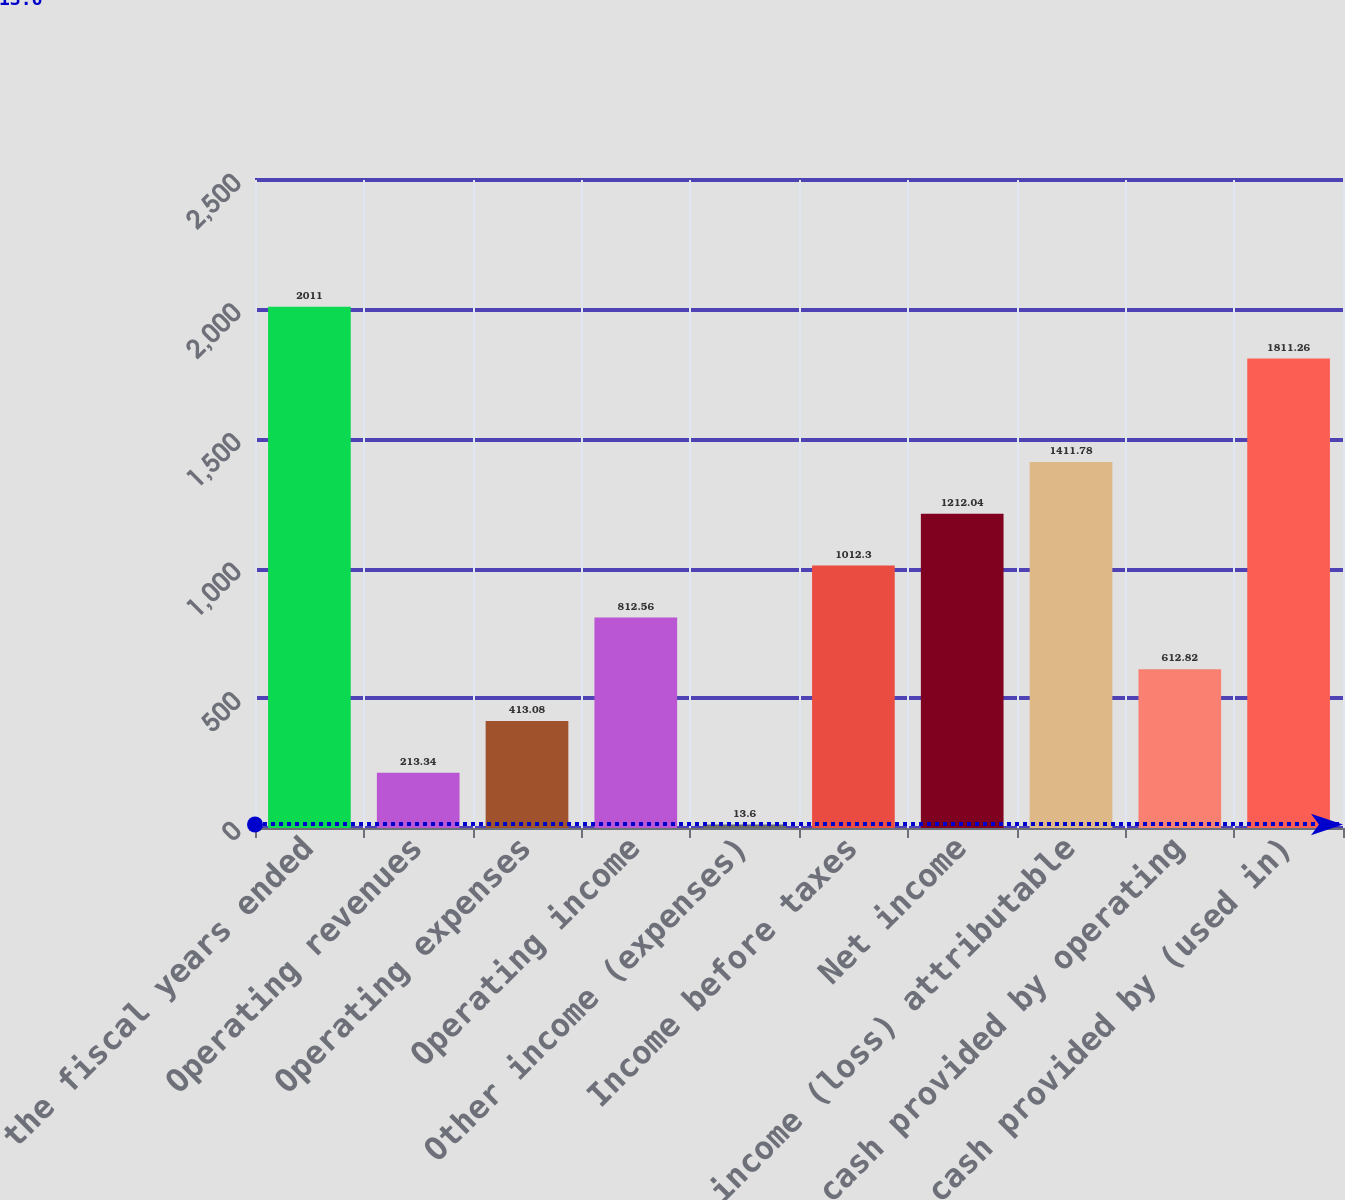Convert chart. <chart><loc_0><loc_0><loc_500><loc_500><bar_chart><fcel>for the fiscal years ended<fcel>Operating revenues<fcel>Operating expenses<fcel>Operating income<fcel>Other income (expenses)<fcel>Income before taxes<fcel>Net income<fcel>Net income (loss) attributable<fcel>Net cash provided by operating<fcel>Net cash provided by (used in)<nl><fcel>2011<fcel>213.34<fcel>413.08<fcel>812.56<fcel>13.6<fcel>1012.3<fcel>1212.04<fcel>1411.78<fcel>612.82<fcel>1811.26<nl></chart> 